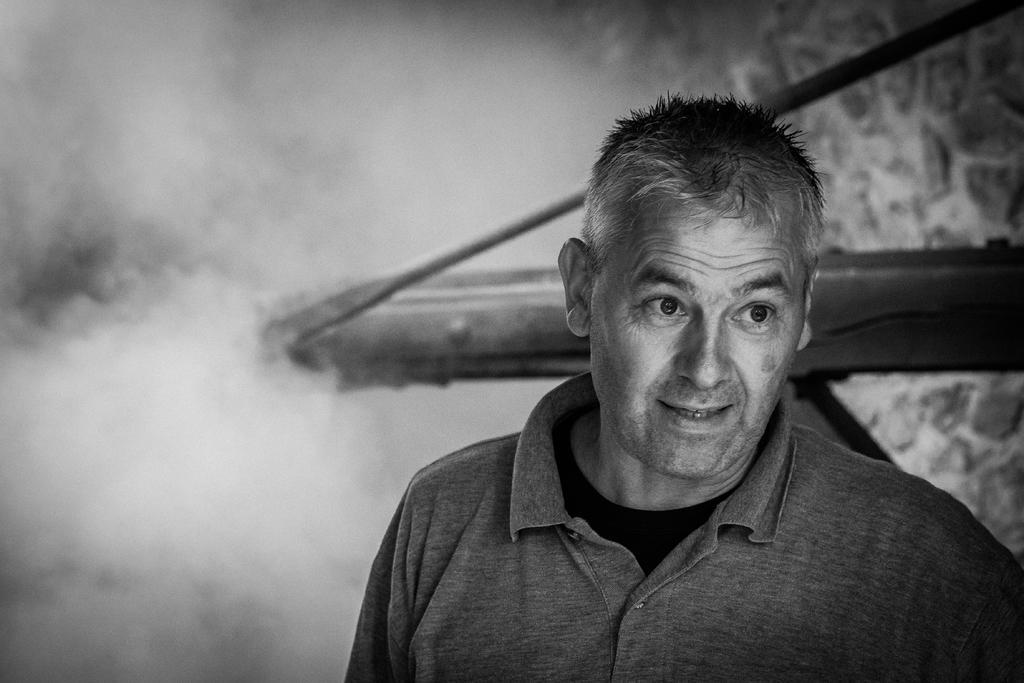Could you give a brief overview of what you see in this image? This image consists of a person standing in the center having some expression on his face. In the background there is some smoke and a wooden stand. 